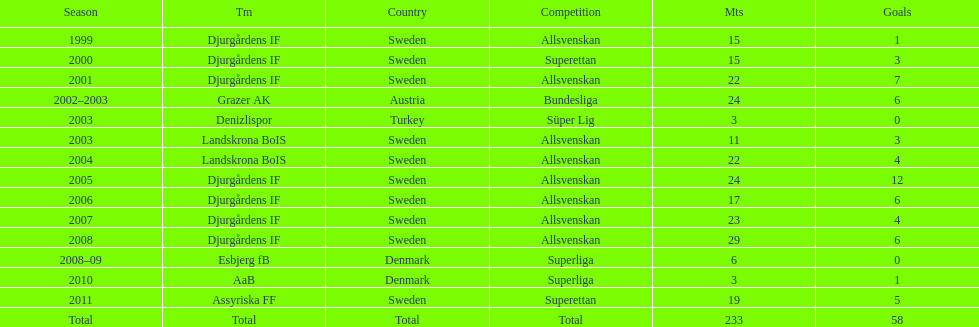What is the total number of matches? 233. 